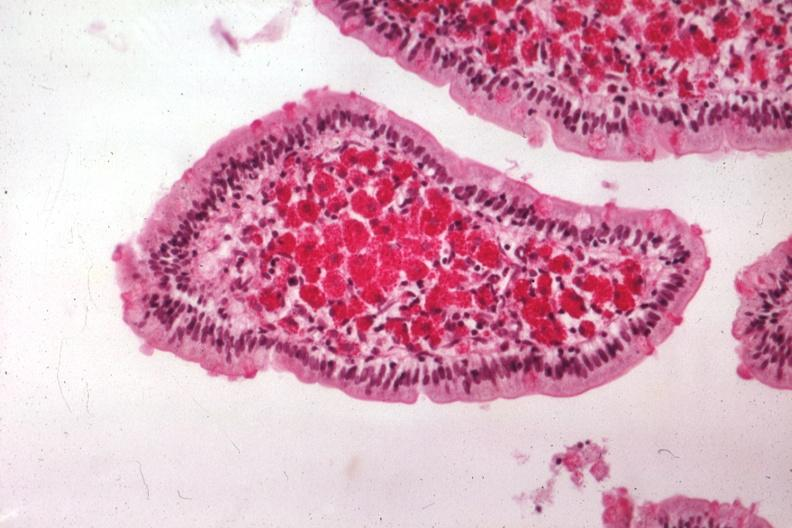does cytomegaly show med pas hematoxylin excellent demonstration source?
Answer the question using a single word or phrase. No 